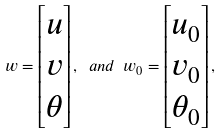Convert formula to latex. <formula><loc_0><loc_0><loc_500><loc_500>w = \begin{bmatrix} u \\ v \\ \theta \end{bmatrix} , \ a n d \ w _ { 0 } = \begin{bmatrix} u _ { 0 } \\ v _ { 0 } \\ \theta _ { 0 } \end{bmatrix} ,</formula> 